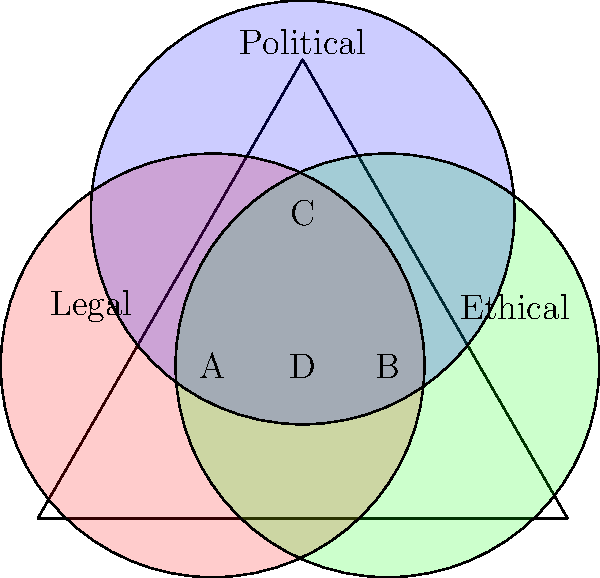In the Venn diagram, areas A, B, and C represent considerations that are exclusively legal, ethical, and political, respectively. Area D represents the overlap of all three. As a government official, which area would you focus on to ensure your decisions are most comprehensive and defensible? To answer this question, let's analyze each area of the Venn diagram:

1. Area A: Exclusively legal considerations
2. Area B: Exclusively ethical considerations
3. Area C: Exclusively political considerations
4. Area D: Overlap of legal, ethical, and political considerations

As a government official, focusing on area D would be most beneficial for several reasons:

1. Comprehensiveness: Area D represents decisions that satisfy legal, ethical, and political requirements simultaneously. This ensures that all aspects of governance are considered.

2. Defensibility: Decisions made in area D are easier to defend as they comply with legal standards, adhere to ethical principles, and consider political implications.

3. Balance: By focusing on the intersection of all three areas, you avoid overemphasizing one aspect at the expense of others.

4. Risk mitigation: Decisions made in area D are less likely to face challenges from legal, ethical, or political perspectives, reducing potential risks and controversies.

5. Public trust: When decisions incorporate legal, ethical, and political considerations, they are more likely to be perceived as fair and just by the public.

6. Long-term sustainability: Decisions that balance all three aspects are more likely to stand the test of time and remain valid across different political climates.

Therefore, as a government official who values ethical decision-making (as influenced by the law professor's teachings), focusing on area D would allow you to make the most comprehensive and defensible decisions.
Answer: Area D 